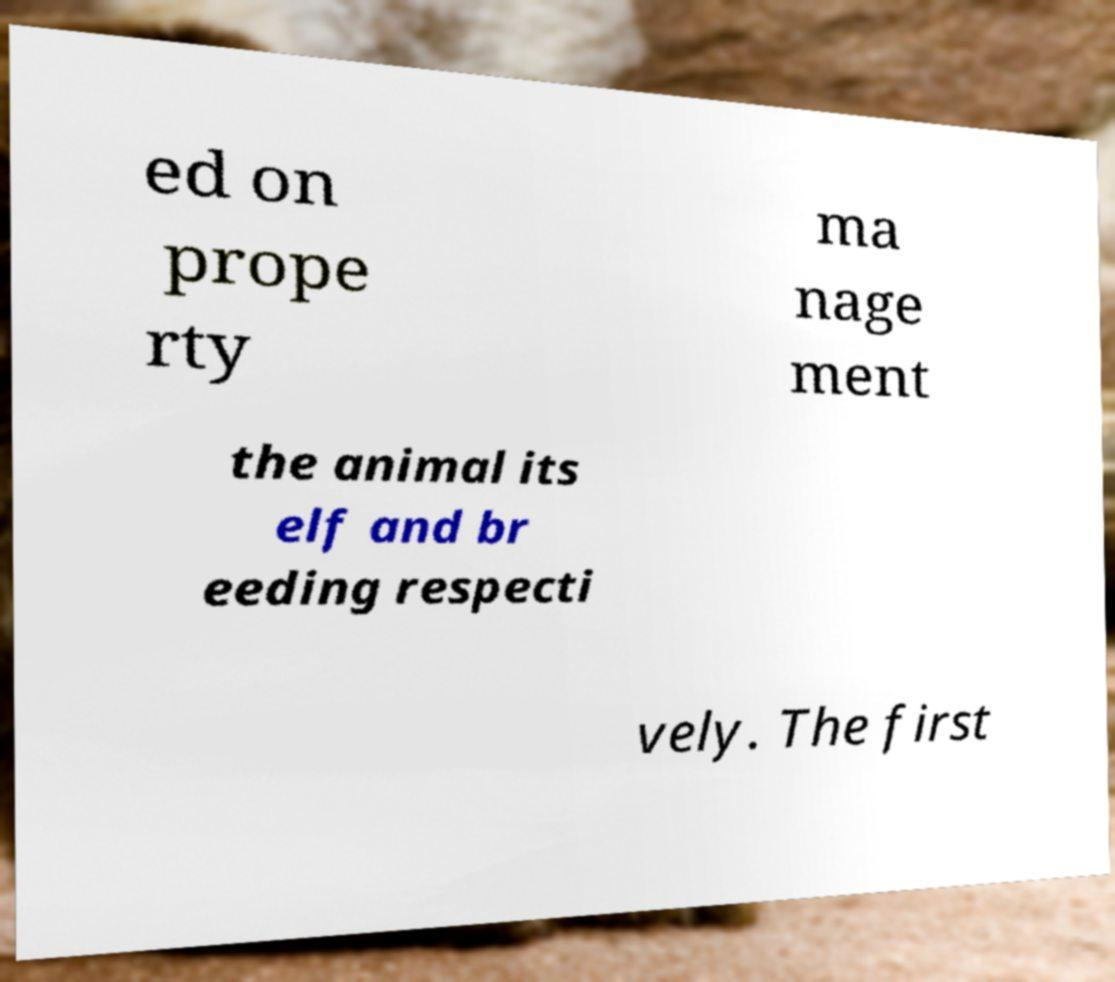Can you accurately transcribe the text from the provided image for me? ed on prope rty ma nage ment the animal its elf and br eeding respecti vely. The first 